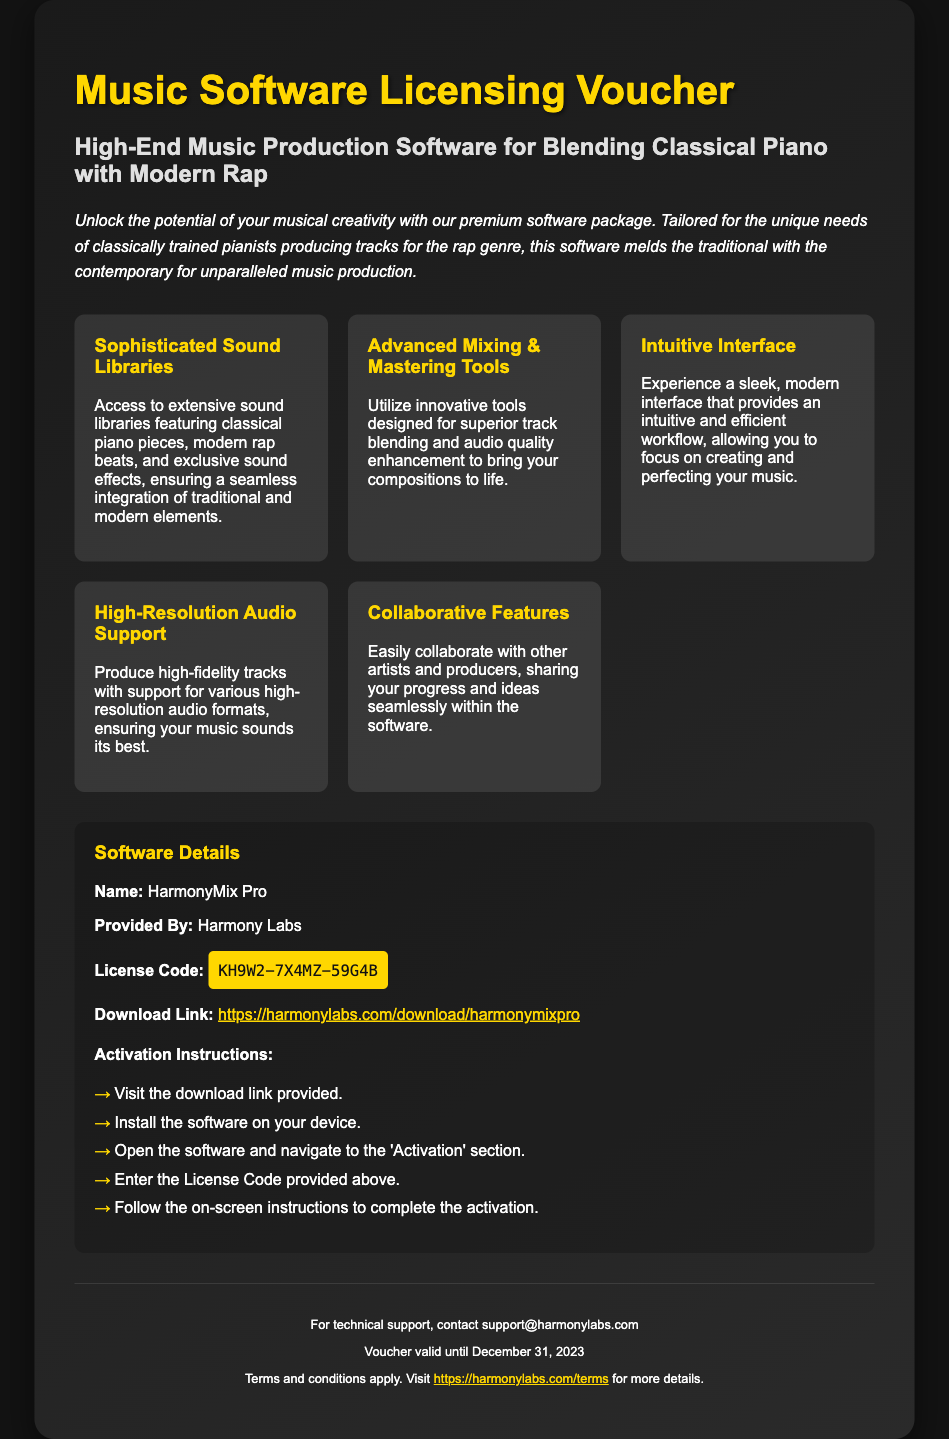What is the name of the software? The software is named in the document as part of the software details section.
Answer: HarmonyMix Pro Who is the provider of the software? The provider of the software is mentioned in the software details section.
Answer: Harmony Labs What is the license code provided? The license code is explicitly stated in the software details section of the document.
Answer: KH9W2-7X4MZ-59G4B When does the voucher expire? The expiration date is specified in the footer section of the document.
Answer: December 31, 2023 What type of tools does the software offer for track blending? The document highlights the type of tools available for mixing and mastering.
Answer: Advanced Mixing & Mastering Tools How can users activate the software? The activation instructions are listed step-by-step within the software details section.
Answer: Enter the License Code provided above What design feature is mentioned about the software's interface? The specific attribute of the software interface is described in the features section.
Answer: Intuitive Interface What is the download link for the software? The document includes a direct link to download the software in the software details section.
Answer: https://harmonylabs.com/download/harmonymixpro 